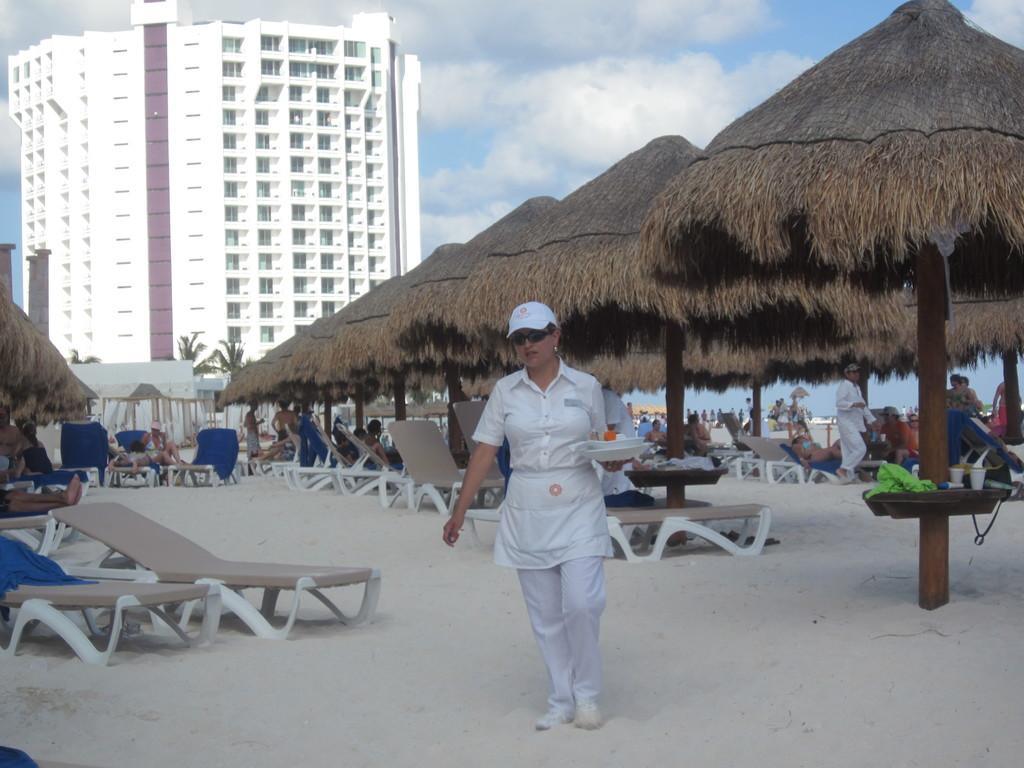Can you describe this image briefly? In this image we can see a woman on the sandy land. She is wearing white color dress and holding balls in her hand. Behind her, we can see beds, people and grass umbrellas. We can see one white color building with glass windows and the sky is covered with clouds. 